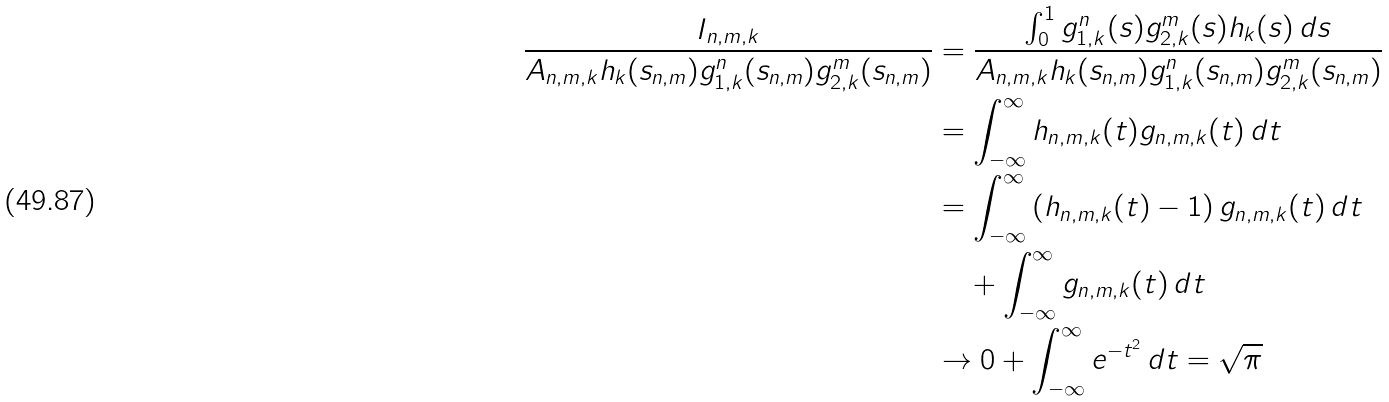Convert formula to latex. <formula><loc_0><loc_0><loc_500><loc_500>\frac { I _ { n , m , k } } { A _ { n , m , k } h _ { k } ( s _ { n , m } ) g _ { 1 , k } ^ { n } ( s _ { n , m } ) g _ { 2 , k } ^ { m } ( s _ { n , m } ) } & = \frac { \int _ { 0 } ^ { 1 } g _ { 1 , k } ^ { n } ( s ) g _ { 2 , k } ^ { m } ( s ) h _ { k } ( s ) \, d s } { A _ { n , m , k } h _ { k } ( s _ { n , m } ) g _ { 1 , k } ^ { n } ( s _ { n , m } ) g _ { 2 , k } ^ { m } ( s _ { n , m } ) } \\ & = \int _ { - \infty } ^ { \infty } h _ { n , m , k } ( t ) g _ { n , m , k } ( t ) \, d t \\ & = \int _ { - \infty } ^ { \infty } \left ( h _ { n , m , k } ( t ) - 1 \right ) g _ { n , m , k } ( t ) \, d t \\ & \, \quad + \int _ { - \infty } ^ { \infty } g _ { n , m , k } ( t ) \, d t \\ & \to 0 + \int _ { - \infty } ^ { \infty } e ^ { - t ^ { 2 } } \, d t = \sqrt { \pi }</formula> 